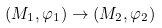Convert formula to latex. <formula><loc_0><loc_0><loc_500><loc_500>( M _ { 1 } , \varphi _ { 1 } ) \rightarrow ( M _ { 2 } , \varphi _ { 2 } )</formula> 